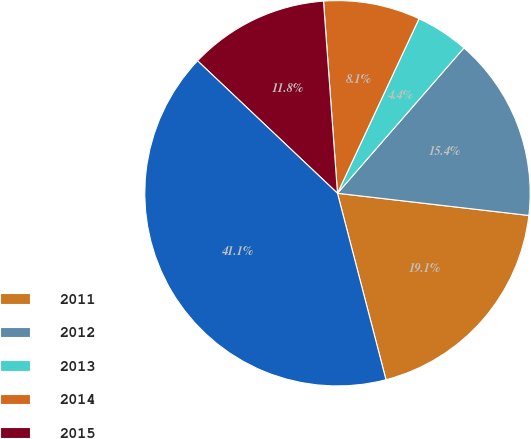Convert chart. <chart><loc_0><loc_0><loc_500><loc_500><pie_chart><fcel>2011<fcel>2012<fcel>2013<fcel>2014<fcel>2015<fcel>Thereafter<nl><fcel>19.11%<fcel>15.44%<fcel>4.44%<fcel>8.11%<fcel>11.78%<fcel>41.11%<nl></chart> 